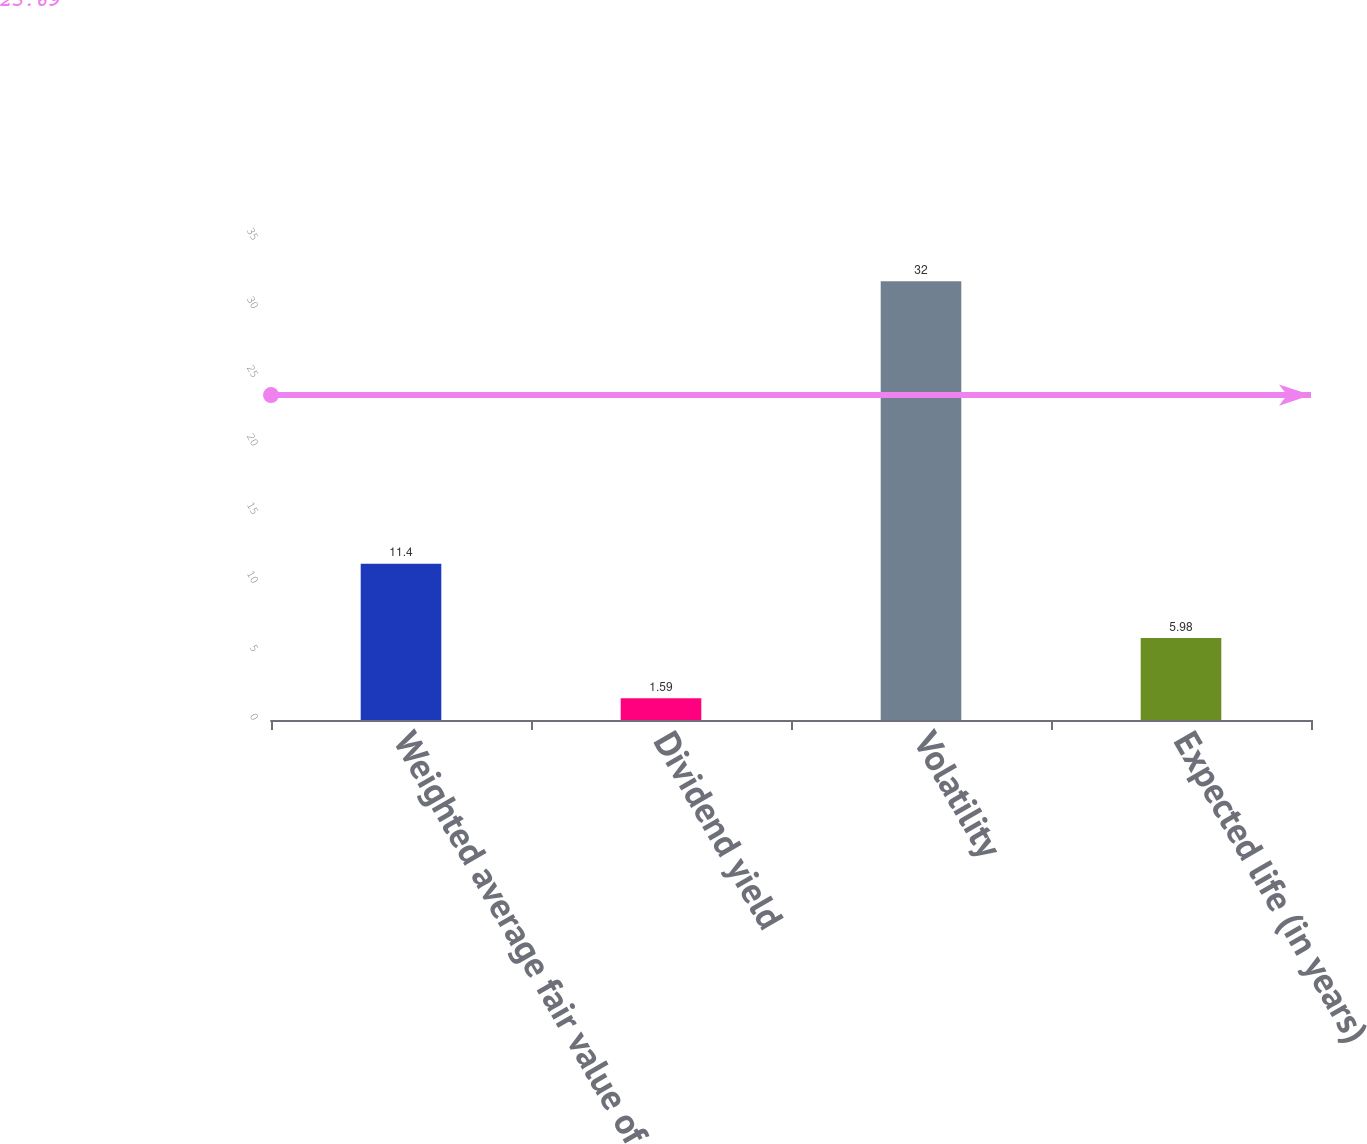Convert chart to OTSL. <chart><loc_0><loc_0><loc_500><loc_500><bar_chart><fcel>Weighted average fair value of<fcel>Dividend yield<fcel>Volatility<fcel>Expected life (in years)<nl><fcel>11.4<fcel>1.59<fcel>32<fcel>5.98<nl></chart> 